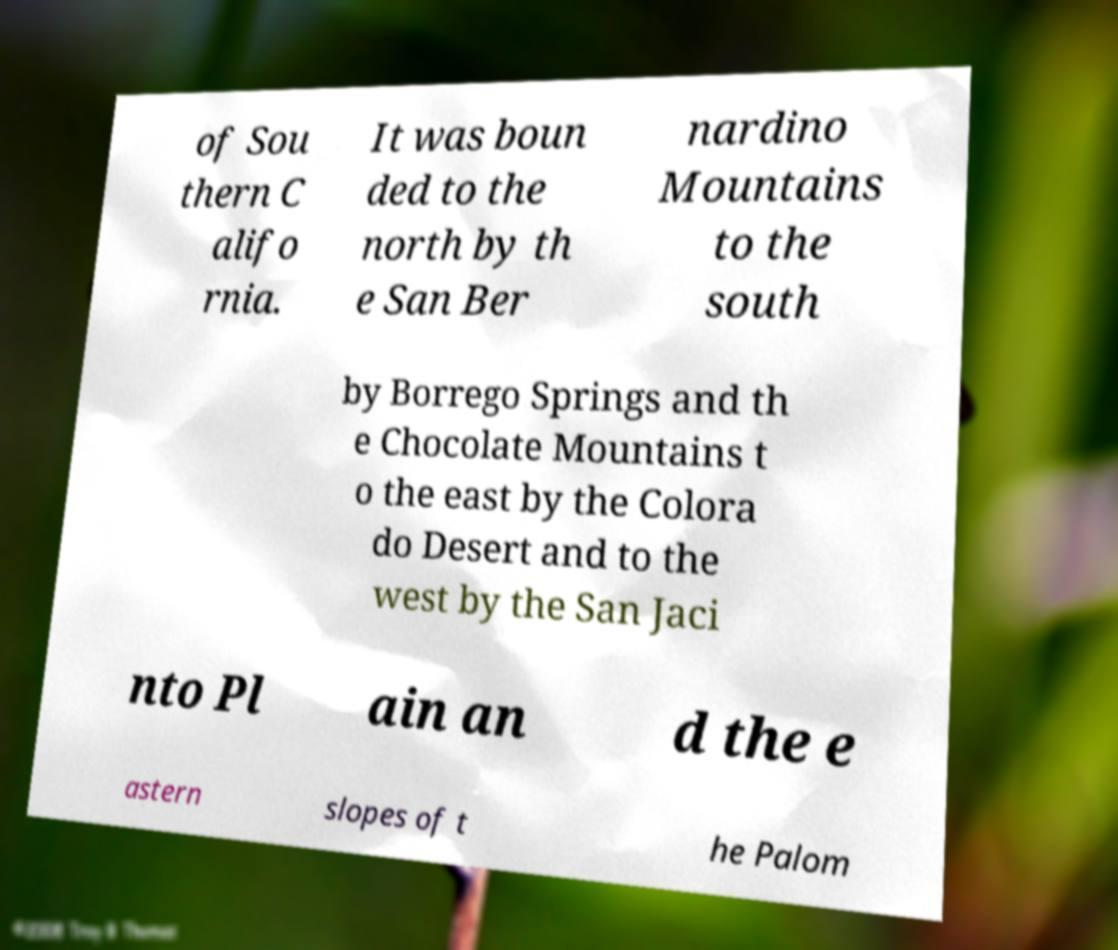Can you read and provide the text displayed in the image?This photo seems to have some interesting text. Can you extract and type it out for me? of Sou thern C alifo rnia. It was boun ded to the north by th e San Ber nardino Mountains to the south by Borrego Springs and th e Chocolate Mountains t o the east by the Colora do Desert and to the west by the San Jaci nto Pl ain an d the e astern slopes of t he Palom 